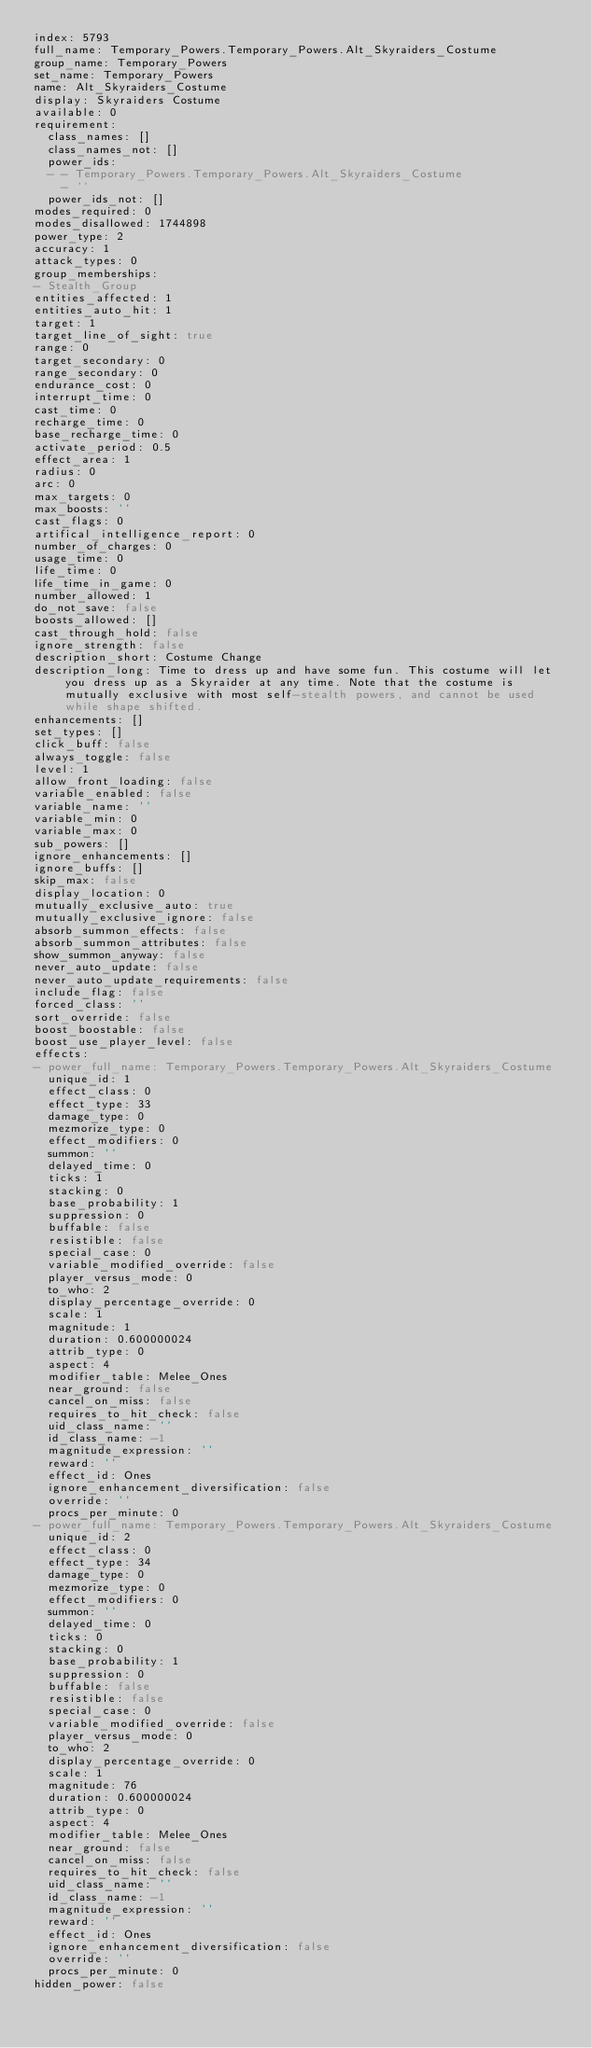<code> <loc_0><loc_0><loc_500><loc_500><_YAML_>index: 5793
full_name: Temporary_Powers.Temporary_Powers.Alt_Skyraiders_Costume
group_name: Temporary_Powers
set_name: Temporary_Powers
name: Alt_Skyraiders_Costume
display: Skyraiders Costume
available: 0
requirement:
  class_names: []
  class_names_not: []
  power_ids:
  - - Temporary_Powers.Temporary_Powers.Alt_Skyraiders_Costume
    - ''
  power_ids_not: []
modes_required: 0
modes_disallowed: 1744898
power_type: 2
accuracy: 1
attack_types: 0
group_memberships:
- Stealth_Group
entities_affected: 1
entities_auto_hit: 1
target: 1
target_line_of_sight: true
range: 0
target_secondary: 0
range_secondary: 0
endurance_cost: 0
interrupt_time: 0
cast_time: 0
recharge_time: 0
base_recharge_time: 0
activate_period: 0.5
effect_area: 1
radius: 0
arc: 0
max_targets: 0
max_boosts: ''
cast_flags: 0
artifical_intelligence_report: 0
number_of_charges: 0
usage_time: 0
life_time: 0
life_time_in_game: 0
number_allowed: 1
do_not_save: false
boosts_allowed: []
cast_through_hold: false
ignore_strength: false
description_short: Costume Change
description_long: Time to dress up and have some fun. This costume will let you dress up as a Skyraider at any time. Note that the costume is mutually exclusive with most self-stealth powers, and cannot be used while shape shifted.
enhancements: []
set_types: []
click_buff: false
always_toggle: false
level: 1
allow_front_loading: false
variable_enabled: false
variable_name: ''
variable_min: 0
variable_max: 0
sub_powers: []
ignore_enhancements: []
ignore_buffs: []
skip_max: false
display_location: 0
mutually_exclusive_auto: true
mutually_exclusive_ignore: false
absorb_summon_effects: false
absorb_summon_attributes: false
show_summon_anyway: false
never_auto_update: false
never_auto_update_requirements: false
include_flag: false
forced_class: ''
sort_override: false
boost_boostable: false
boost_use_player_level: false
effects:
- power_full_name: Temporary_Powers.Temporary_Powers.Alt_Skyraiders_Costume
  unique_id: 1
  effect_class: 0
  effect_type: 33
  damage_type: 0
  mezmorize_type: 0
  effect_modifiers: 0
  summon: ''
  delayed_time: 0
  ticks: 1
  stacking: 0
  base_probability: 1
  suppression: 0
  buffable: false
  resistible: false
  special_case: 0
  variable_modified_override: false
  player_versus_mode: 0
  to_who: 2
  display_percentage_override: 0
  scale: 1
  magnitude: 1
  duration: 0.600000024
  attrib_type: 0
  aspect: 4
  modifier_table: Melee_Ones
  near_ground: false
  cancel_on_miss: false
  requires_to_hit_check: false
  uid_class_name: ''
  id_class_name: -1
  magnitude_expression: ''
  reward: ''
  effect_id: Ones
  ignore_enhancement_diversification: false
  override: ''
  procs_per_minute: 0
- power_full_name: Temporary_Powers.Temporary_Powers.Alt_Skyraiders_Costume
  unique_id: 2
  effect_class: 0
  effect_type: 34
  damage_type: 0
  mezmorize_type: 0
  effect_modifiers: 0
  summon: ''
  delayed_time: 0
  ticks: 0
  stacking: 0
  base_probability: 1
  suppression: 0
  buffable: false
  resistible: false
  special_case: 0
  variable_modified_override: false
  player_versus_mode: 0
  to_who: 2
  display_percentage_override: 0
  scale: 1
  magnitude: 76
  duration: 0.600000024
  attrib_type: 0
  aspect: 4
  modifier_table: Melee_Ones
  near_ground: false
  cancel_on_miss: false
  requires_to_hit_check: false
  uid_class_name: ''
  id_class_name: -1
  magnitude_expression: ''
  reward: ''
  effect_id: Ones
  ignore_enhancement_diversification: false
  override: ''
  procs_per_minute: 0
hidden_power: false
</code> 